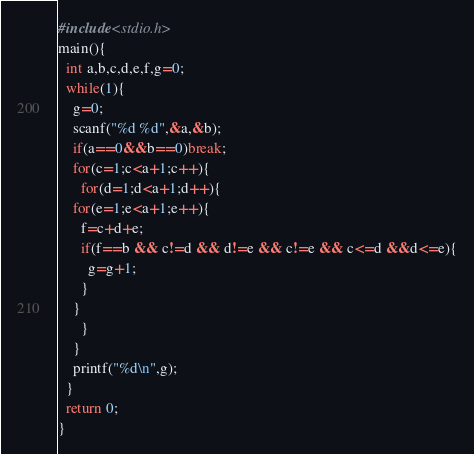<code> <loc_0><loc_0><loc_500><loc_500><_C_>#include<stdio.h>
main(){
  int a,b,c,d,e,f,g=0;
  while(1){
    g=0;
    scanf("%d %d",&a,&b);
    if(a==0&&b==0)break;
    for(c=1;c<a+1;c++){
      for(d=1;d<a+1;d++){
	for(e=1;e<a+1;e++){
	  f=c+d+e;
	  if(f==b && c!=d && d!=e && c!=e && c<=d &&d<=e){
	    g=g+1;
	  }
	}
      }
    }
    printf("%d\n",g);
  }
  return 0;
}</code> 